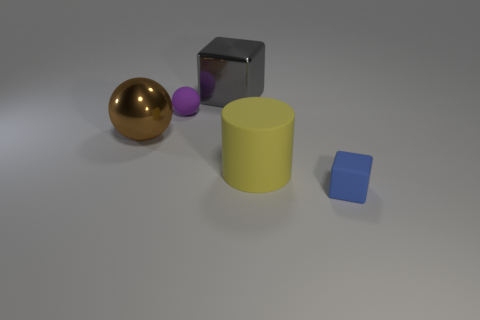Add 2 yellow things. How many objects exist? 7 Subtract all blocks. How many objects are left? 3 Add 4 gray objects. How many gray objects are left? 5 Add 5 large metal cubes. How many large metal cubes exist? 6 Subtract 0 red blocks. How many objects are left? 5 Subtract all gray cubes. Subtract all big brown matte objects. How many objects are left? 4 